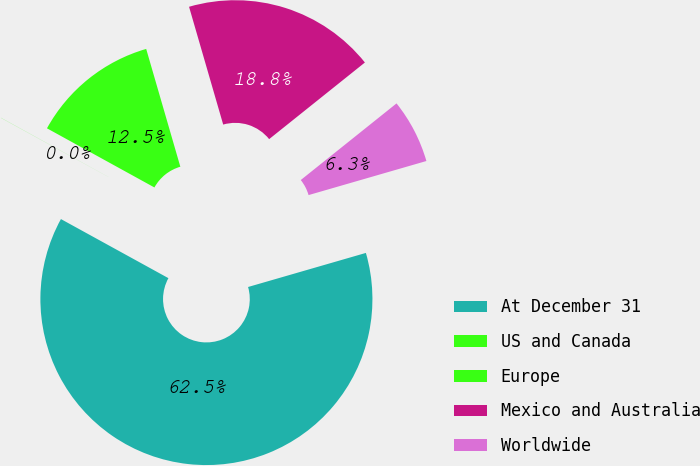Convert chart to OTSL. <chart><loc_0><loc_0><loc_500><loc_500><pie_chart><fcel>At December 31<fcel>US and Canada<fcel>Europe<fcel>Mexico and Australia<fcel>Worldwide<nl><fcel>62.48%<fcel>0.01%<fcel>12.5%<fcel>18.75%<fcel>6.26%<nl></chart> 